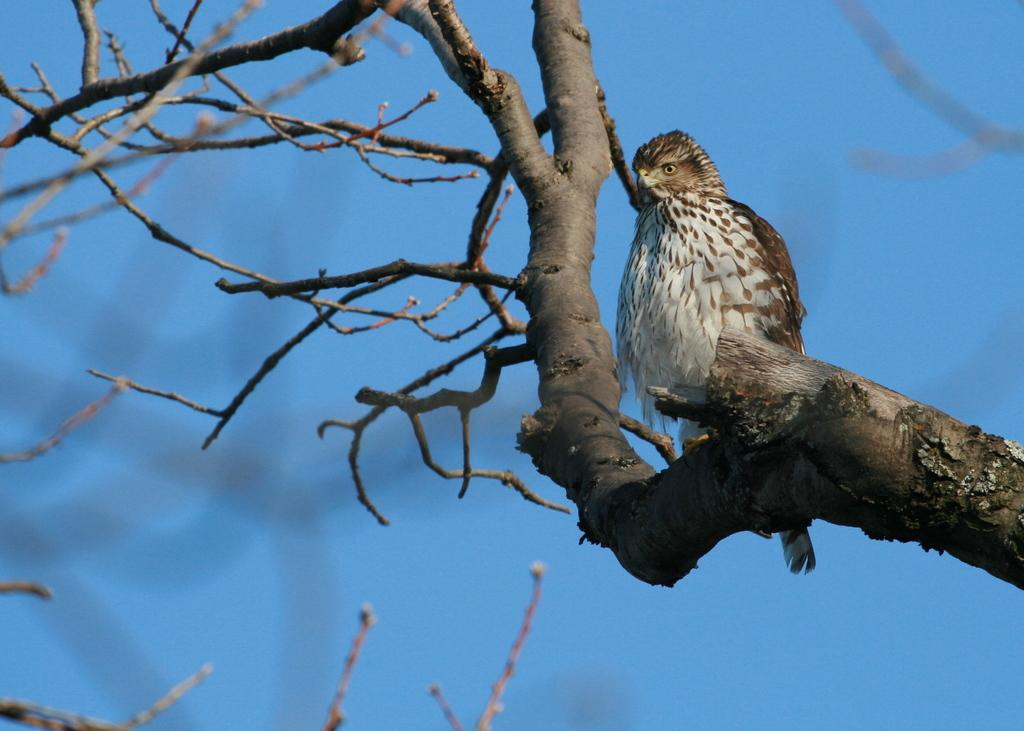What type of animal is present in the image? There is a bird in the image. Where is the bird located in the image? The bird is on the branch of a tree. What color is the background of the image? The background of the image is blue in color. How many events are listed on the calendar in the image? There is no calendar present in the image. What type of corn is visible in the image? There is no corn present in the image. 